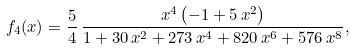<formula> <loc_0><loc_0><loc_500><loc_500>f _ { 4 } ( x ) = { \frac { 5 } { 4 } } \, { \frac { { x } ^ { 4 } \left ( - 1 + 5 \, { x } ^ { 2 } \right ) } { 1 + 3 0 \, { x } ^ { 2 } + 2 7 3 \, { x } ^ { 4 } + 8 2 0 \, { x } ^ { 6 } + 5 7 6 \, { x } ^ { 8 } } } ,</formula> 